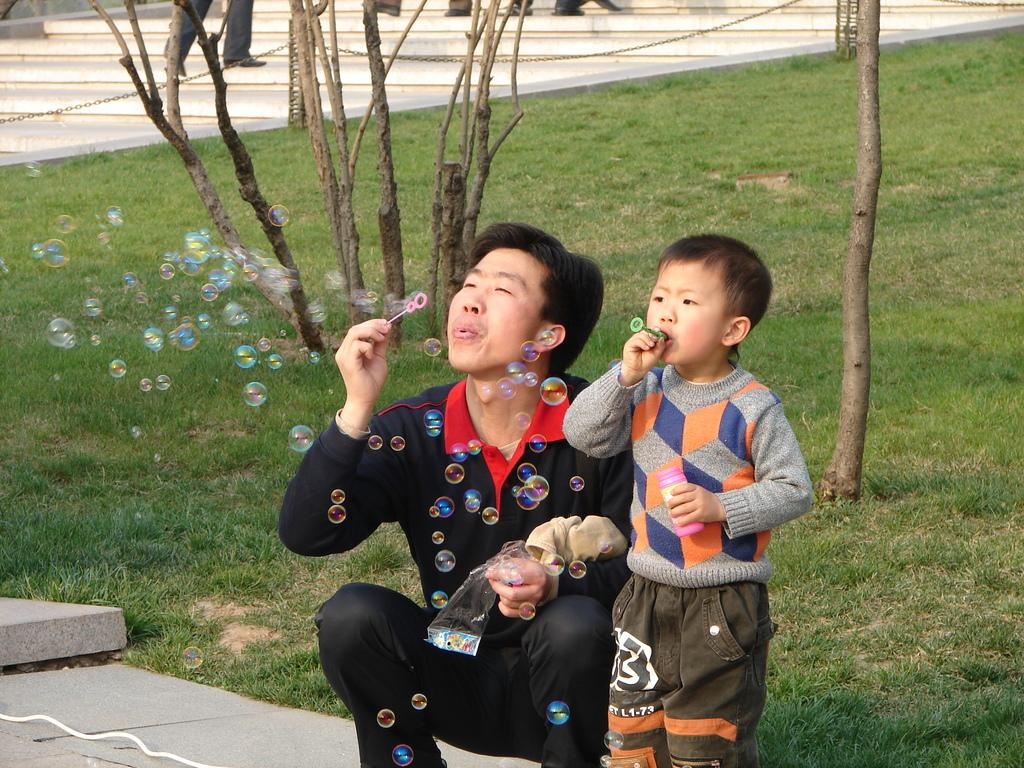Who is present in the image? There is a man and a boy in the image. What are the man and the boy doing in the image? Both the man and the boy are blowing bubbles. What can be seen in the background of the image? There are tree trunks and legs of people visible in the background of the image. What is the ground made of in the image? There is grass on the ground in the image. What type of plate is being used to catch the bubbles in the image? A: There is no plate visible in the image; the man and the boy are blowing bubbles into the air. What kind of roof can be seen in the image? There is no roof present in the image; it is an outdoor scene with grass and trees. 